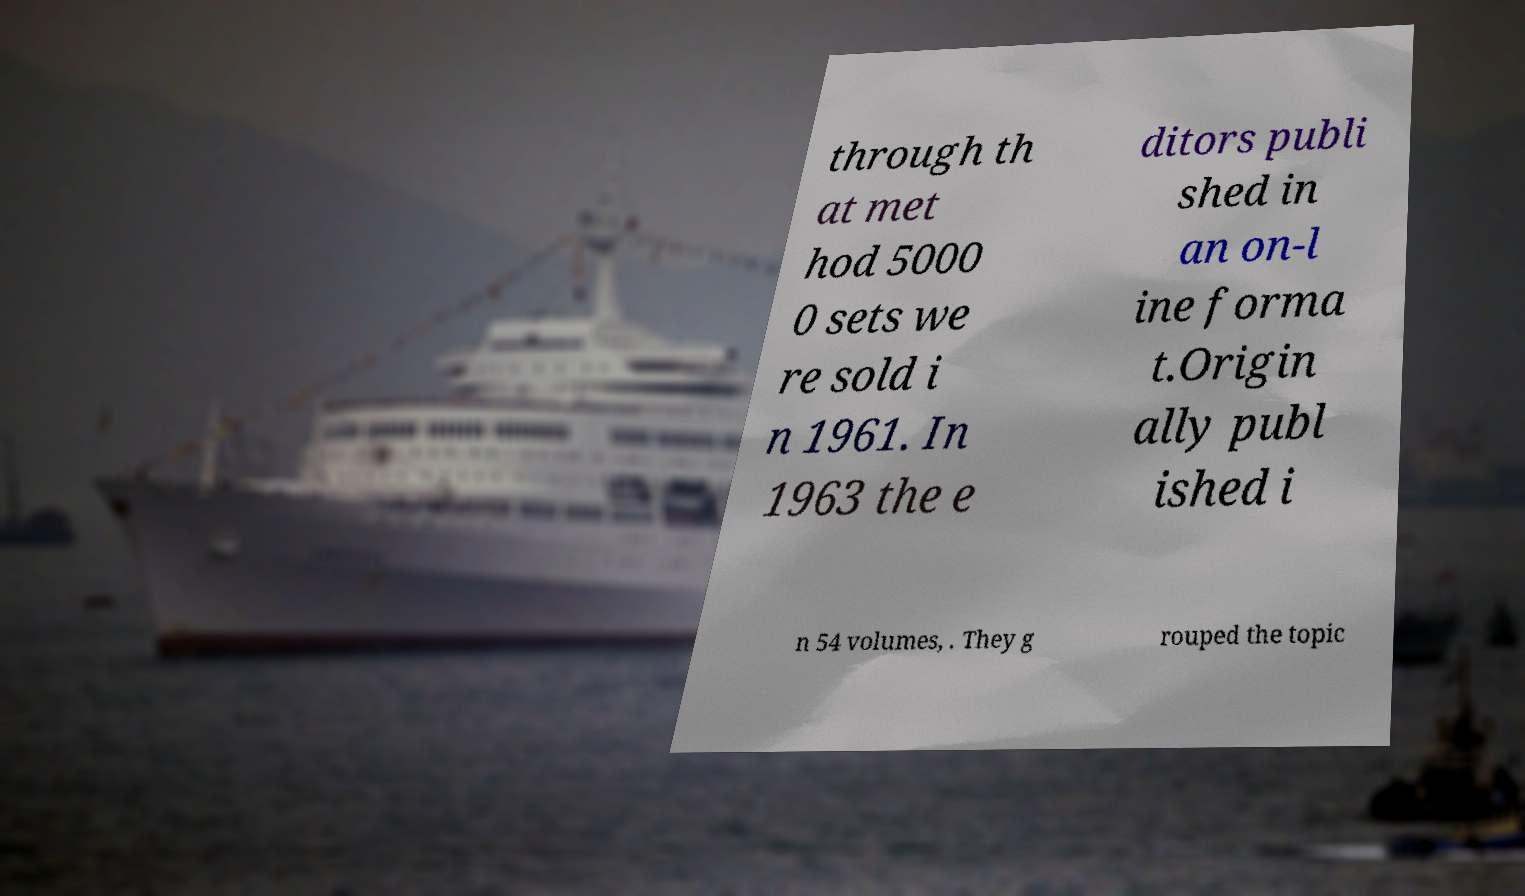For documentation purposes, I need the text within this image transcribed. Could you provide that? through th at met hod 5000 0 sets we re sold i n 1961. In 1963 the e ditors publi shed in an on-l ine forma t.Origin ally publ ished i n 54 volumes, . They g rouped the topic 